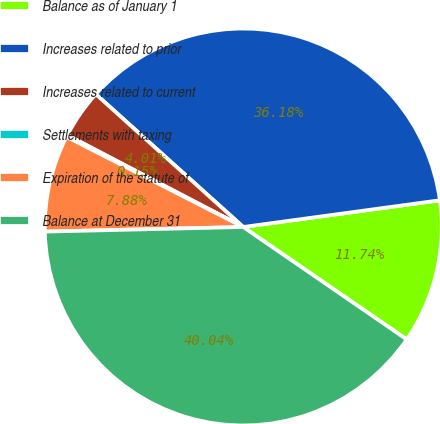<chart> <loc_0><loc_0><loc_500><loc_500><pie_chart><fcel>Balance as of January 1<fcel>Increases related to prior<fcel>Increases related to current<fcel>Settlements with taxing<fcel>Expiration of the statute of<fcel>Balance at December 31<nl><fcel>11.74%<fcel>36.18%<fcel>4.01%<fcel>0.15%<fcel>7.88%<fcel>40.04%<nl></chart> 